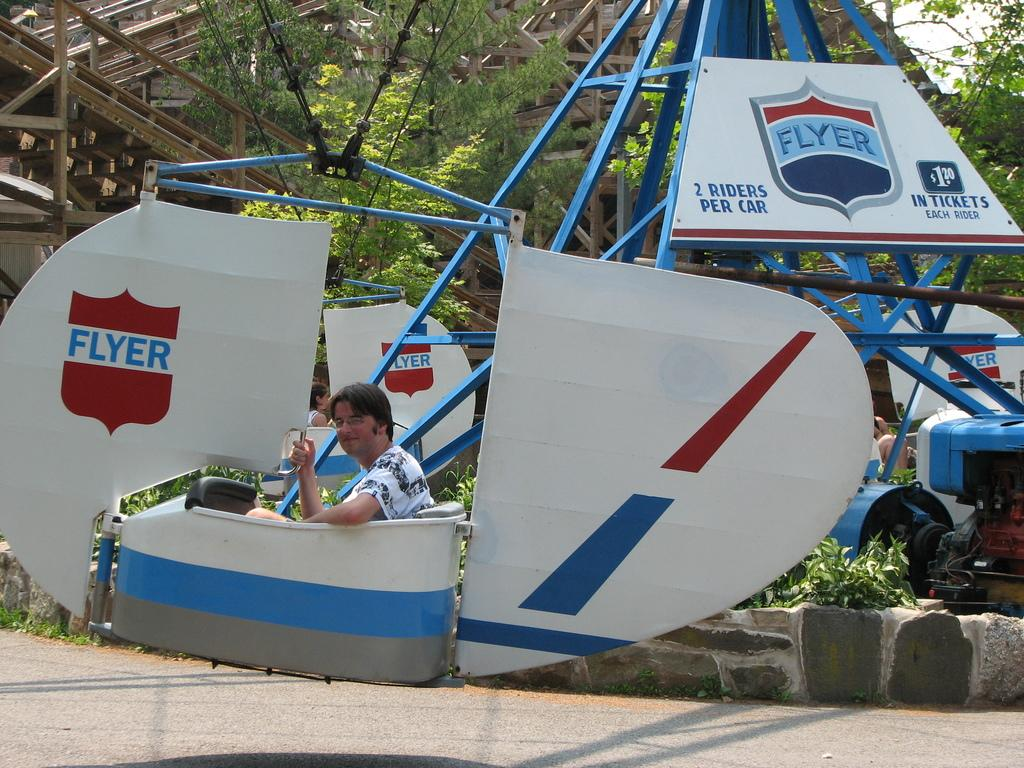<image>
Relay a brief, clear account of the picture shown. Man sitting on a ride which says 2 riders per car. 